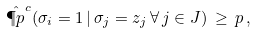Convert formula to latex. <formula><loc_0><loc_0><loc_500><loc_500>\hat { \P p } ^ { c } ( \sigma _ { i } = 1 \, | \, \sigma _ { j } = z _ { j } \, \forall \, j \in J ) \, \geq \, p \, ,</formula> 